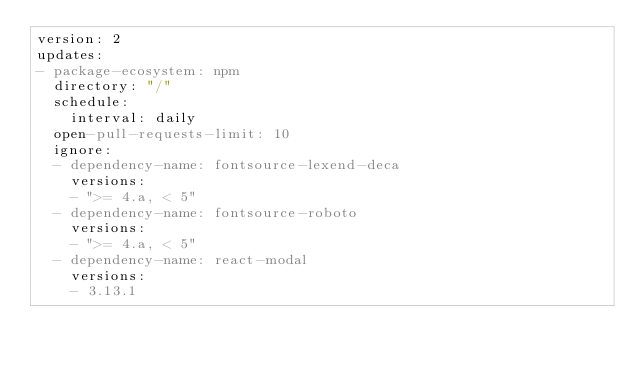Convert code to text. <code><loc_0><loc_0><loc_500><loc_500><_YAML_>version: 2
updates:
- package-ecosystem: npm
  directory: "/"
  schedule:
    interval: daily
  open-pull-requests-limit: 10
  ignore:
  - dependency-name: fontsource-lexend-deca
    versions:
    - ">= 4.a, < 5"
  - dependency-name: fontsource-roboto
    versions:
    - ">= 4.a, < 5"
  - dependency-name: react-modal
    versions:
    - 3.13.1
</code> 